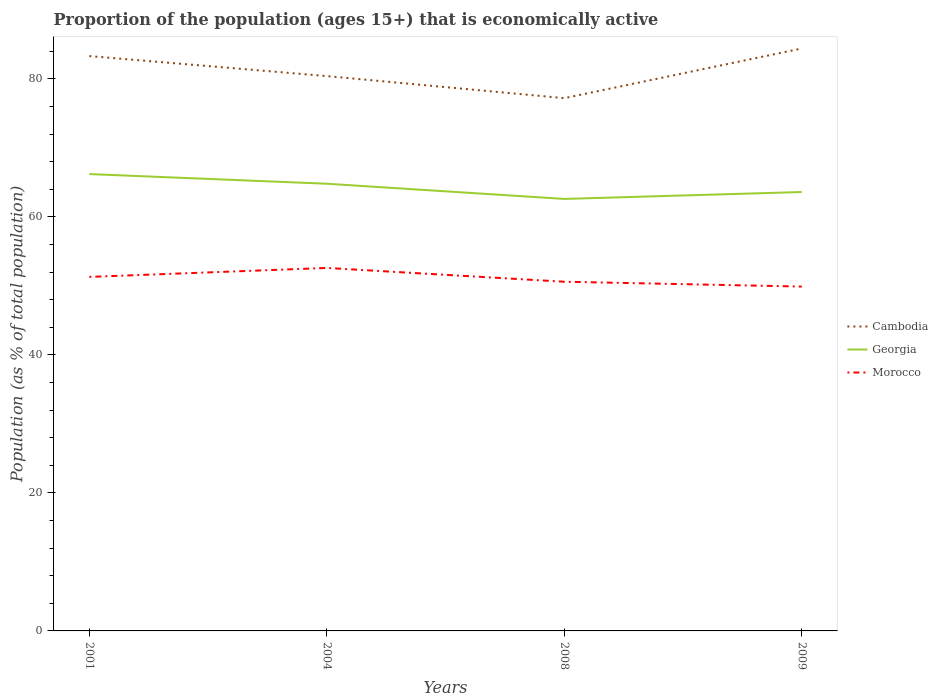Does the line corresponding to Georgia intersect with the line corresponding to Cambodia?
Ensure brevity in your answer.  No. Is the number of lines equal to the number of legend labels?
Your answer should be compact. Yes. Across all years, what is the maximum proportion of the population that is economically active in Cambodia?
Offer a very short reply. 77.2. What is the total proportion of the population that is economically active in Georgia in the graph?
Ensure brevity in your answer.  2.2. What is the difference between the highest and the second highest proportion of the population that is economically active in Cambodia?
Offer a very short reply. 7.2. How many lines are there?
Your answer should be compact. 3. How many years are there in the graph?
Offer a terse response. 4. Are the values on the major ticks of Y-axis written in scientific E-notation?
Provide a succinct answer. No. Does the graph contain any zero values?
Provide a short and direct response. No. Does the graph contain grids?
Your answer should be compact. No. Where does the legend appear in the graph?
Ensure brevity in your answer.  Center right. How many legend labels are there?
Your answer should be compact. 3. What is the title of the graph?
Keep it short and to the point. Proportion of the population (ages 15+) that is economically active. What is the label or title of the X-axis?
Make the answer very short. Years. What is the label or title of the Y-axis?
Offer a very short reply. Population (as % of total population). What is the Population (as % of total population) in Cambodia in 2001?
Give a very brief answer. 83.3. What is the Population (as % of total population) in Georgia in 2001?
Ensure brevity in your answer.  66.2. What is the Population (as % of total population) in Morocco in 2001?
Provide a succinct answer. 51.3. What is the Population (as % of total population) of Cambodia in 2004?
Your answer should be compact. 80.4. What is the Population (as % of total population) in Georgia in 2004?
Keep it short and to the point. 64.8. What is the Population (as % of total population) of Morocco in 2004?
Give a very brief answer. 52.6. What is the Population (as % of total population) in Cambodia in 2008?
Your response must be concise. 77.2. What is the Population (as % of total population) of Georgia in 2008?
Keep it short and to the point. 62.6. What is the Population (as % of total population) in Morocco in 2008?
Offer a terse response. 50.6. What is the Population (as % of total population) in Cambodia in 2009?
Offer a very short reply. 84.4. What is the Population (as % of total population) in Georgia in 2009?
Offer a very short reply. 63.6. What is the Population (as % of total population) in Morocco in 2009?
Keep it short and to the point. 49.9. Across all years, what is the maximum Population (as % of total population) in Cambodia?
Give a very brief answer. 84.4. Across all years, what is the maximum Population (as % of total population) in Georgia?
Provide a short and direct response. 66.2. Across all years, what is the maximum Population (as % of total population) of Morocco?
Offer a very short reply. 52.6. Across all years, what is the minimum Population (as % of total population) of Cambodia?
Your answer should be very brief. 77.2. Across all years, what is the minimum Population (as % of total population) in Georgia?
Your answer should be very brief. 62.6. Across all years, what is the minimum Population (as % of total population) of Morocco?
Ensure brevity in your answer.  49.9. What is the total Population (as % of total population) of Cambodia in the graph?
Offer a terse response. 325.3. What is the total Population (as % of total population) in Georgia in the graph?
Make the answer very short. 257.2. What is the total Population (as % of total population) of Morocco in the graph?
Keep it short and to the point. 204.4. What is the difference between the Population (as % of total population) of Georgia in 2001 and that in 2004?
Ensure brevity in your answer.  1.4. What is the difference between the Population (as % of total population) of Cambodia in 2001 and that in 2008?
Offer a very short reply. 6.1. What is the difference between the Population (as % of total population) in Georgia in 2001 and that in 2008?
Offer a terse response. 3.6. What is the difference between the Population (as % of total population) of Georgia in 2001 and that in 2009?
Keep it short and to the point. 2.6. What is the difference between the Population (as % of total population) of Cambodia in 2004 and that in 2008?
Make the answer very short. 3.2. What is the difference between the Population (as % of total population) of Morocco in 2004 and that in 2008?
Make the answer very short. 2. What is the difference between the Population (as % of total population) in Cambodia in 2004 and that in 2009?
Ensure brevity in your answer.  -4. What is the difference between the Population (as % of total population) of Morocco in 2004 and that in 2009?
Make the answer very short. 2.7. What is the difference between the Population (as % of total population) in Cambodia in 2008 and that in 2009?
Give a very brief answer. -7.2. What is the difference between the Population (as % of total population) in Cambodia in 2001 and the Population (as % of total population) in Georgia in 2004?
Make the answer very short. 18.5. What is the difference between the Population (as % of total population) in Cambodia in 2001 and the Population (as % of total population) in Morocco in 2004?
Keep it short and to the point. 30.7. What is the difference between the Population (as % of total population) of Georgia in 2001 and the Population (as % of total population) of Morocco in 2004?
Give a very brief answer. 13.6. What is the difference between the Population (as % of total population) of Cambodia in 2001 and the Population (as % of total population) of Georgia in 2008?
Ensure brevity in your answer.  20.7. What is the difference between the Population (as % of total population) of Cambodia in 2001 and the Population (as % of total population) of Morocco in 2008?
Ensure brevity in your answer.  32.7. What is the difference between the Population (as % of total population) of Georgia in 2001 and the Population (as % of total population) of Morocco in 2008?
Offer a very short reply. 15.6. What is the difference between the Population (as % of total population) in Cambodia in 2001 and the Population (as % of total population) in Morocco in 2009?
Make the answer very short. 33.4. What is the difference between the Population (as % of total population) in Cambodia in 2004 and the Population (as % of total population) in Georgia in 2008?
Ensure brevity in your answer.  17.8. What is the difference between the Population (as % of total population) of Cambodia in 2004 and the Population (as % of total population) of Morocco in 2008?
Your answer should be very brief. 29.8. What is the difference between the Population (as % of total population) of Georgia in 2004 and the Population (as % of total population) of Morocco in 2008?
Make the answer very short. 14.2. What is the difference between the Population (as % of total population) in Cambodia in 2004 and the Population (as % of total population) in Georgia in 2009?
Your answer should be compact. 16.8. What is the difference between the Population (as % of total population) in Cambodia in 2004 and the Population (as % of total population) in Morocco in 2009?
Keep it short and to the point. 30.5. What is the difference between the Population (as % of total population) in Cambodia in 2008 and the Population (as % of total population) in Georgia in 2009?
Your answer should be compact. 13.6. What is the difference between the Population (as % of total population) of Cambodia in 2008 and the Population (as % of total population) of Morocco in 2009?
Offer a terse response. 27.3. What is the difference between the Population (as % of total population) in Georgia in 2008 and the Population (as % of total population) in Morocco in 2009?
Make the answer very short. 12.7. What is the average Population (as % of total population) of Cambodia per year?
Make the answer very short. 81.33. What is the average Population (as % of total population) of Georgia per year?
Keep it short and to the point. 64.3. What is the average Population (as % of total population) of Morocco per year?
Your response must be concise. 51.1. In the year 2001, what is the difference between the Population (as % of total population) of Cambodia and Population (as % of total population) of Georgia?
Provide a succinct answer. 17.1. In the year 2001, what is the difference between the Population (as % of total population) in Georgia and Population (as % of total population) in Morocco?
Your response must be concise. 14.9. In the year 2004, what is the difference between the Population (as % of total population) in Cambodia and Population (as % of total population) in Morocco?
Make the answer very short. 27.8. In the year 2004, what is the difference between the Population (as % of total population) of Georgia and Population (as % of total population) of Morocco?
Your answer should be compact. 12.2. In the year 2008, what is the difference between the Population (as % of total population) of Cambodia and Population (as % of total population) of Georgia?
Offer a terse response. 14.6. In the year 2008, what is the difference between the Population (as % of total population) of Cambodia and Population (as % of total population) of Morocco?
Your answer should be compact. 26.6. In the year 2008, what is the difference between the Population (as % of total population) of Georgia and Population (as % of total population) of Morocco?
Offer a terse response. 12. In the year 2009, what is the difference between the Population (as % of total population) of Cambodia and Population (as % of total population) of Georgia?
Offer a terse response. 20.8. In the year 2009, what is the difference between the Population (as % of total population) in Cambodia and Population (as % of total population) in Morocco?
Ensure brevity in your answer.  34.5. What is the ratio of the Population (as % of total population) of Cambodia in 2001 to that in 2004?
Ensure brevity in your answer.  1.04. What is the ratio of the Population (as % of total population) in Georgia in 2001 to that in 2004?
Provide a succinct answer. 1.02. What is the ratio of the Population (as % of total population) in Morocco in 2001 to that in 2004?
Keep it short and to the point. 0.98. What is the ratio of the Population (as % of total population) of Cambodia in 2001 to that in 2008?
Offer a very short reply. 1.08. What is the ratio of the Population (as % of total population) of Georgia in 2001 to that in 2008?
Make the answer very short. 1.06. What is the ratio of the Population (as % of total population) in Morocco in 2001 to that in 2008?
Provide a succinct answer. 1.01. What is the ratio of the Population (as % of total population) of Cambodia in 2001 to that in 2009?
Offer a very short reply. 0.99. What is the ratio of the Population (as % of total population) in Georgia in 2001 to that in 2009?
Provide a succinct answer. 1.04. What is the ratio of the Population (as % of total population) of Morocco in 2001 to that in 2009?
Provide a succinct answer. 1.03. What is the ratio of the Population (as % of total population) of Cambodia in 2004 to that in 2008?
Ensure brevity in your answer.  1.04. What is the ratio of the Population (as % of total population) of Georgia in 2004 to that in 2008?
Make the answer very short. 1.04. What is the ratio of the Population (as % of total population) of Morocco in 2004 to that in 2008?
Give a very brief answer. 1.04. What is the ratio of the Population (as % of total population) of Cambodia in 2004 to that in 2009?
Make the answer very short. 0.95. What is the ratio of the Population (as % of total population) in Georgia in 2004 to that in 2009?
Your answer should be very brief. 1.02. What is the ratio of the Population (as % of total population) in Morocco in 2004 to that in 2009?
Provide a short and direct response. 1.05. What is the ratio of the Population (as % of total population) of Cambodia in 2008 to that in 2009?
Your response must be concise. 0.91. What is the ratio of the Population (as % of total population) in Georgia in 2008 to that in 2009?
Ensure brevity in your answer.  0.98. What is the difference between the highest and the second highest Population (as % of total population) of Cambodia?
Offer a very short reply. 1.1. What is the difference between the highest and the lowest Population (as % of total population) in Morocco?
Ensure brevity in your answer.  2.7. 